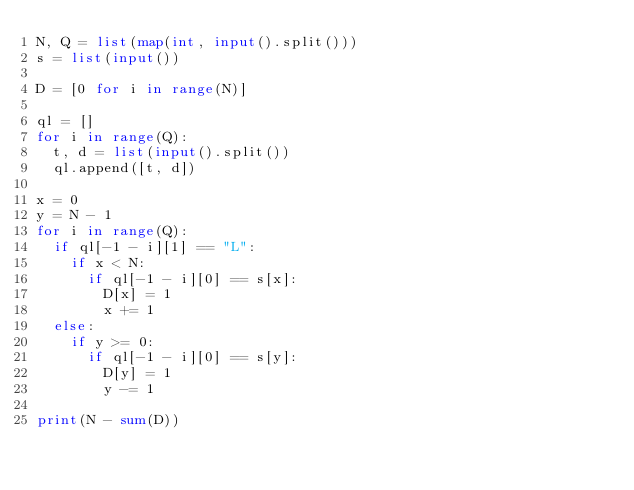<code> <loc_0><loc_0><loc_500><loc_500><_Python_>N, Q = list(map(int, input().split()))
s = list(input())

D = [0 for i in range(N)]

ql = []
for i in range(Q):
	t, d = list(input().split())
	ql.append([t, d])

x = 0
y = N - 1
for i in range(Q):
	if ql[-1 - i][1] == "L":
		if x < N:
			if ql[-1 - i][0] == s[x]:
				D[x] = 1
				x += 1
	else:
		if y >= 0:
			if ql[-1 - i][0] == s[y]:
				D[y] = 1
				y -= 1

print(N - sum(D))</code> 